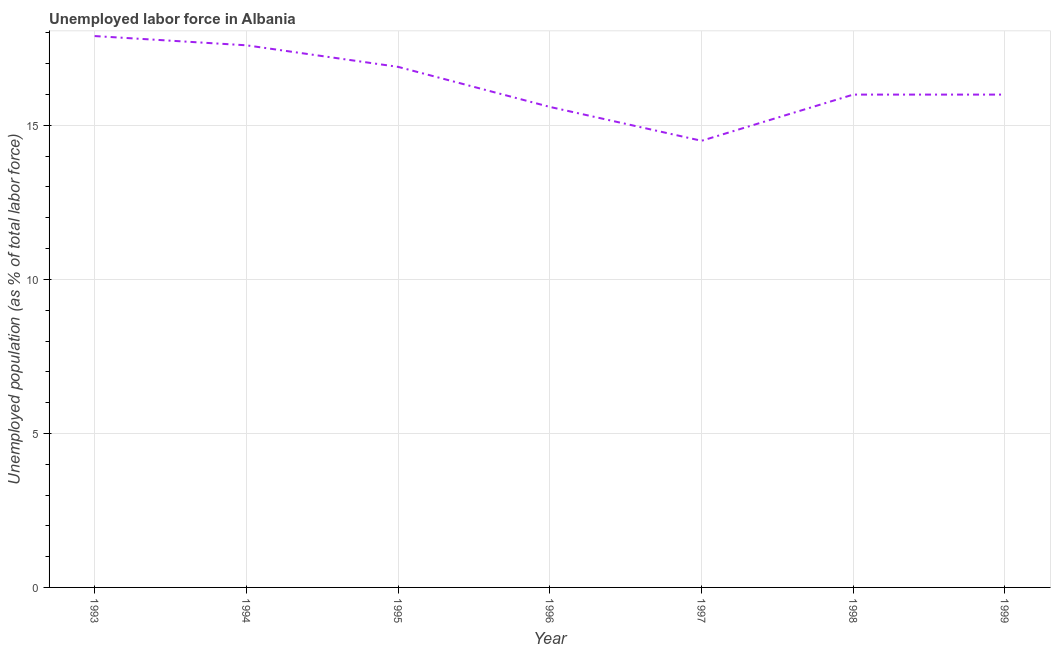What is the total unemployed population in 1995?
Give a very brief answer. 16.9. Across all years, what is the maximum total unemployed population?
Ensure brevity in your answer.  17.9. Across all years, what is the minimum total unemployed population?
Your answer should be compact. 14.5. In which year was the total unemployed population maximum?
Make the answer very short. 1993. In which year was the total unemployed population minimum?
Give a very brief answer. 1997. What is the sum of the total unemployed population?
Provide a short and direct response. 114.5. What is the difference between the total unemployed population in 1997 and 1998?
Keep it short and to the point. -1.5. What is the average total unemployed population per year?
Ensure brevity in your answer.  16.36. In how many years, is the total unemployed population greater than 12 %?
Keep it short and to the point. 7. What is the ratio of the total unemployed population in 1997 to that in 1999?
Offer a terse response. 0.91. Is the total unemployed population in 1993 less than that in 1996?
Make the answer very short. No. What is the difference between the highest and the second highest total unemployed population?
Provide a succinct answer. 0.3. What is the difference between the highest and the lowest total unemployed population?
Make the answer very short. 3.4. Does the total unemployed population monotonically increase over the years?
Offer a terse response. No. How many lines are there?
Make the answer very short. 1. How many years are there in the graph?
Give a very brief answer. 7. What is the difference between two consecutive major ticks on the Y-axis?
Provide a short and direct response. 5. Does the graph contain grids?
Provide a succinct answer. Yes. What is the title of the graph?
Your answer should be very brief. Unemployed labor force in Albania. What is the label or title of the Y-axis?
Make the answer very short. Unemployed population (as % of total labor force). What is the Unemployed population (as % of total labor force) of 1993?
Provide a short and direct response. 17.9. What is the Unemployed population (as % of total labor force) in 1994?
Your answer should be very brief. 17.6. What is the Unemployed population (as % of total labor force) of 1995?
Ensure brevity in your answer.  16.9. What is the Unemployed population (as % of total labor force) in 1996?
Ensure brevity in your answer.  15.6. What is the Unemployed population (as % of total labor force) in 1998?
Give a very brief answer. 16. What is the difference between the Unemployed population (as % of total labor force) in 1993 and 1999?
Ensure brevity in your answer.  1.9. What is the difference between the Unemployed population (as % of total labor force) in 1994 and 1995?
Your answer should be very brief. 0.7. What is the difference between the Unemployed population (as % of total labor force) in 1994 and 1996?
Offer a very short reply. 2. What is the difference between the Unemployed population (as % of total labor force) in 1995 and 1997?
Provide a succinct answer. 2.4. What is the difference between the Unemployed population (as % of total labor force) in 1995 and 1998?
Offer a very short reply. 0.9. What is the difference between the Unemployed population (as % of total labor force) in 1996 and 1998?
Ensure brevity in your answer.  -0.4. What is the difference between the Unemployed population (as % of total labor force) in 1997 and 1998?
Provide a succinct answer. -1.5. What is the difference between the Unemployed population (as % of total labor force) in 1997 and 1999?
Provide a succinct answer. -1.5. What is the ratio of the Unemployed population (as % of total labor force) in 1993 to that in 1994?
Ensure brevity in your answer.  1.02. What is the ratio of the Unemployed population (as % of total labor force) in 1993 to that in 1995?
Keep it short and to the point. 1.06. What is the ratio of the Unemployed population (as % of total labor force) in 1993 to that in 1996?
Your response must be concise. 1.15. What is the ratio of the Unemployed population (as % of total labor force) in 1993 to that in 1997?
Give a very brief answer. 1.23. What is the ratio of the Unemployed population (as % of total labor force) in 1993 to that in 1998?
Ensure brevity in your answer.  1.12. What is the ratio of the Unemployed population (as % of total labor force) in 1993 to that in 1999?
Ensure brevity in your answer.  1.12. What is the ratio of the Unemployed population (as % of total labor force) in 1994 to that in 1995?
Ensure brevity in your answer.  1.04. What is the ratio of the Unemployed population (as % of total labor force) in 1994 to that in 1996?
Your answer should be very brief. 1.13. What is the ratio of the Unemployed population (as % of total labor force) in 1994 to that in 1997?
Make the answer very short. 1.21. What is the ratio of the Unemployed population (as % of total labor force) in 1994 to that in 1998?
Provide a short and direct response. 1.1. What is the ratio of the Unemployed population (as % of total labor force) in 1994 to that in 1999?
Provide a short and direct response. 1.1. What is the ratio of the Unemployed population (as % of total labor force) in 1995 to that in 1996?
Offer a very short reply. 1.08. What is the ratio of the Unemployed population (as % of total labor force) in 1995 to that in 1997?
Keep it short and to the point. 1.17. What is the ratio of the Unemployed population (as % of total labor force) in 1995 to that in 1998?
Offer a very short reply. 1.06. What is the ratio of the Unemployed population (as % of total labor force) in 1995 to that in 1999?
Your answer should be compact. 1.06. What is the ratio of the Unemployed population (as % of total labor force) in 1996 to that in 1997?
Offer a terse response. 1.08. What is the ratio of the Unemployed population (as % of total labor force) in 1996 to that in 1998?
Your answer should be compact. 0.97. What is the ratio of the Unemployed population (as % of total labor force) in 1996 to that in 1999?
Your answer should be very brief. 0.97. What is the ratio of the Unemployed population (as % of total labor force) in 1997 to that in 1998?
Give a very brief answer. 0.91. What is the ratio of the Unemployed population (as % of total labor force) in 1997 to that in 1999?
Keep it short and to the point. 0.91. What is the ratio of the Unemployed population (as % of total labor force) in 1998 to that in 1999?
Your response must be concise. 1. 